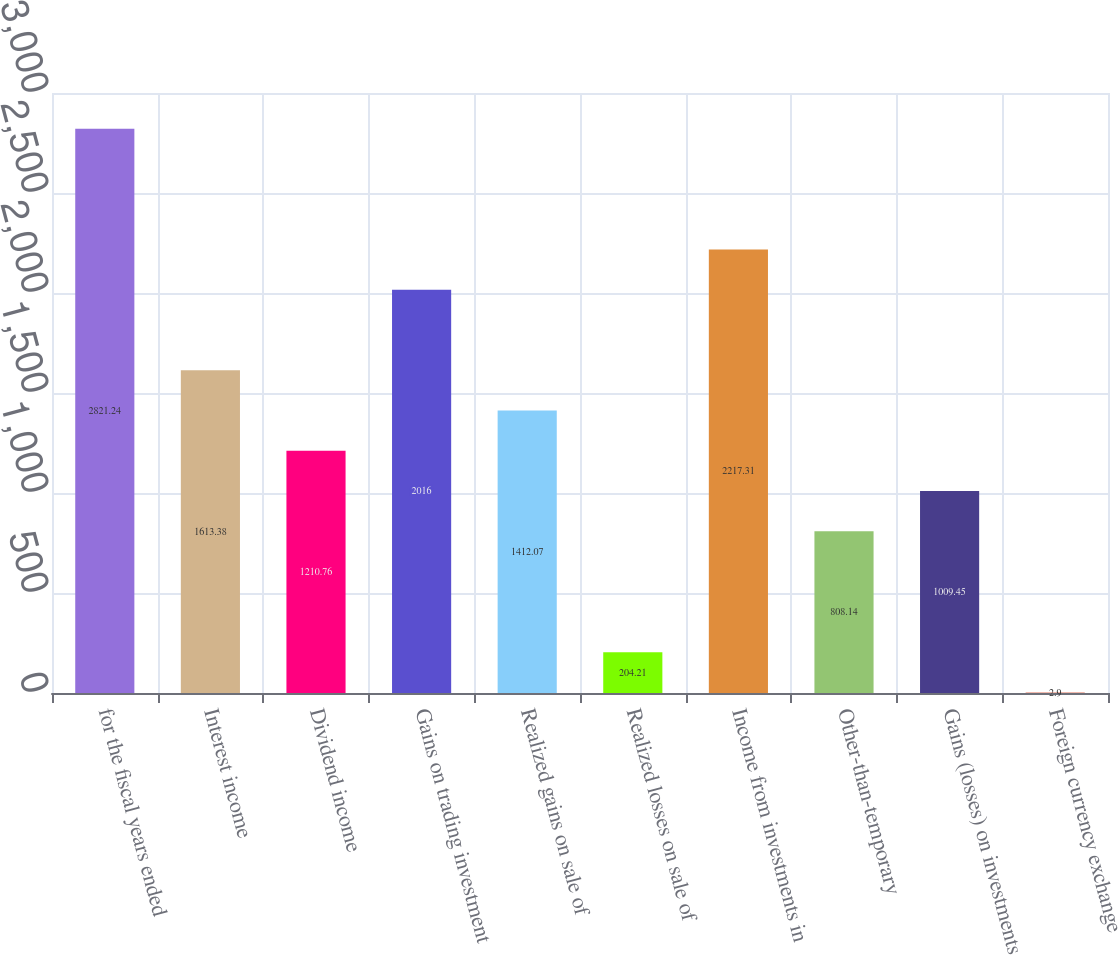Convert chart. <chart><loc_0><loc_0><loc_500><loc_500><bar_chart><fcel>for the fiscal years ended<fcel>Interest income<fcel>Dividend income<fcel>Gains on trading investment<fcel>Realized gains on sale of<fcel>Realized losses on sale of<fcel>Income from investments in<fcel>Other-than-temporary<fcel>Gains (losses) on investments<fcel>Foreign currency exchange<nl><fcel>2821.24<fcel>1613.38<fcel>1210.76<fcel>2016<fcel>1412.07<fcel>204.21<fcel>2217.31<fcel>808.14<fcel>1009.45<fcel>2.9<nl></chart> 